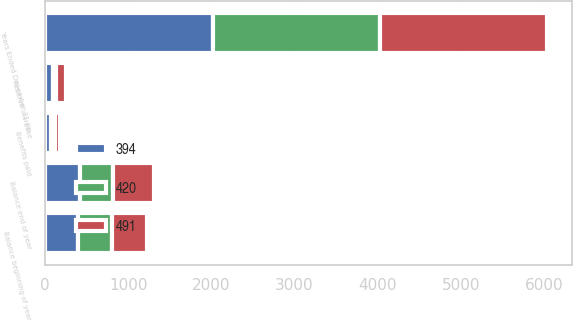Convert chart. <chart><loc_0><loc_0><loc_500><loc_500><stacked_bar_chart><ecel><fcel>Years Ended December 31 (in<fcel>Balance beginning of year<fcel>Reserve increase<fcel>Benefits paid<fcel>Balance end of year<nl><fcel>491<fcel>2015<fcel>420<fcel>127<fcel>56<fcel>491<nl><fcel>394<fcel>2014<fcel>394<fcel>93<fcel>67<fcel>420<nl><fcel>420<fcel>2013<fcel>413<fcel>32<fcel>51<fcel>394<nl></chart> 